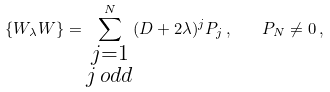<formula> <loc_0><loc_0><loc_500><loc_500>\{ W _ { \lambda } W \} = \sum ^ { N } _ { \substack { j = 1 \\ j \, o d d } } ( D + 2 \lambda ) ^ { j } P _ { j } \, , \quad P _ { N } \neq 0 \, ,</formula> 